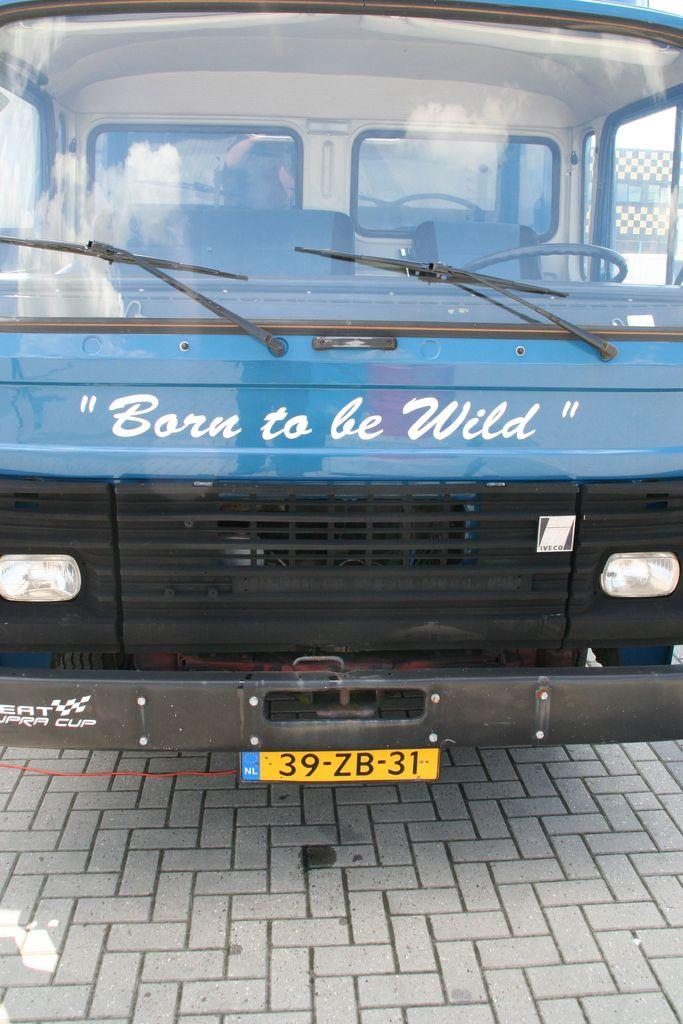<image>
Share a concise interpretation of the image provided. The front of a blue bus with the text "Born to be Wild" written on it 